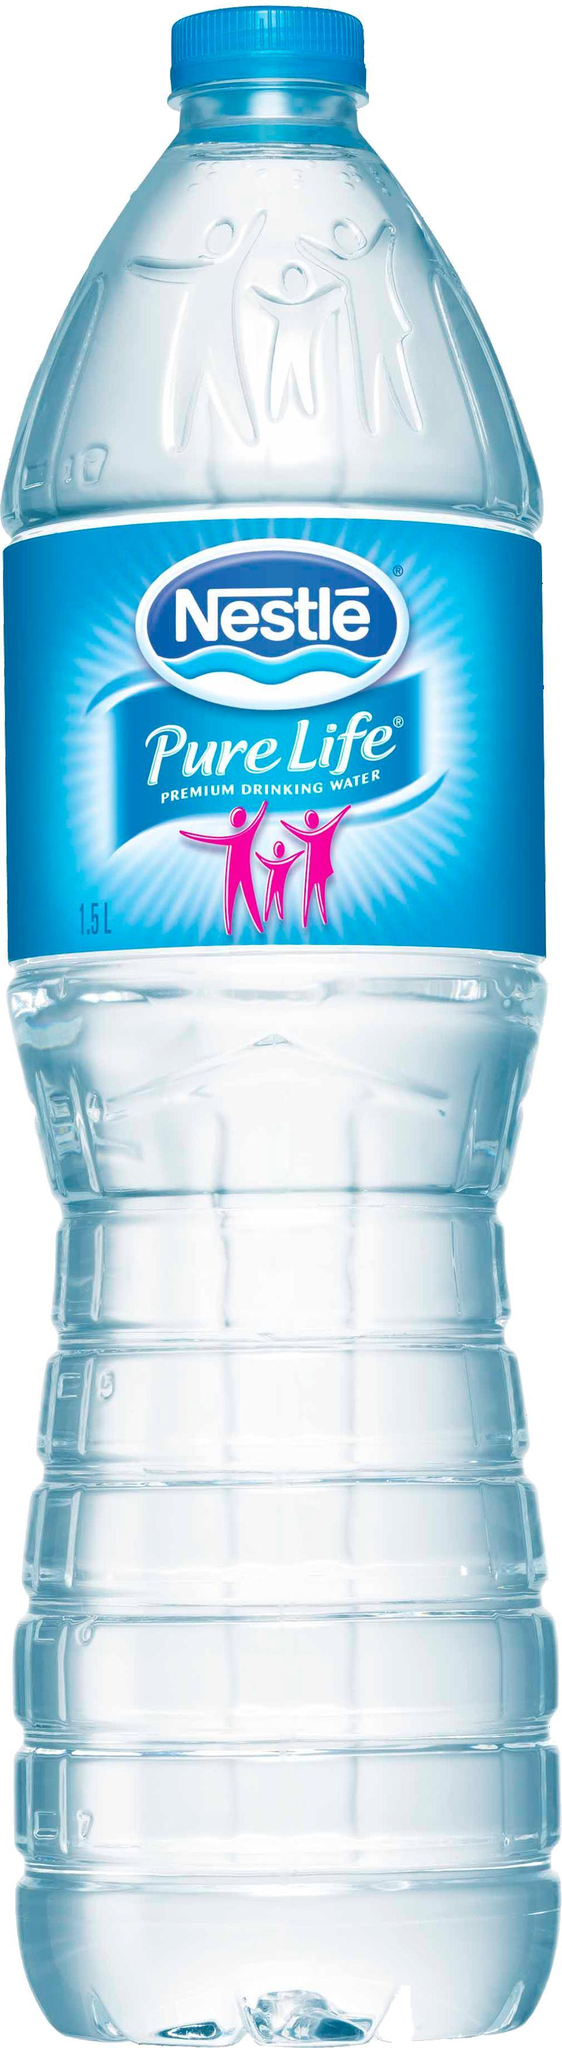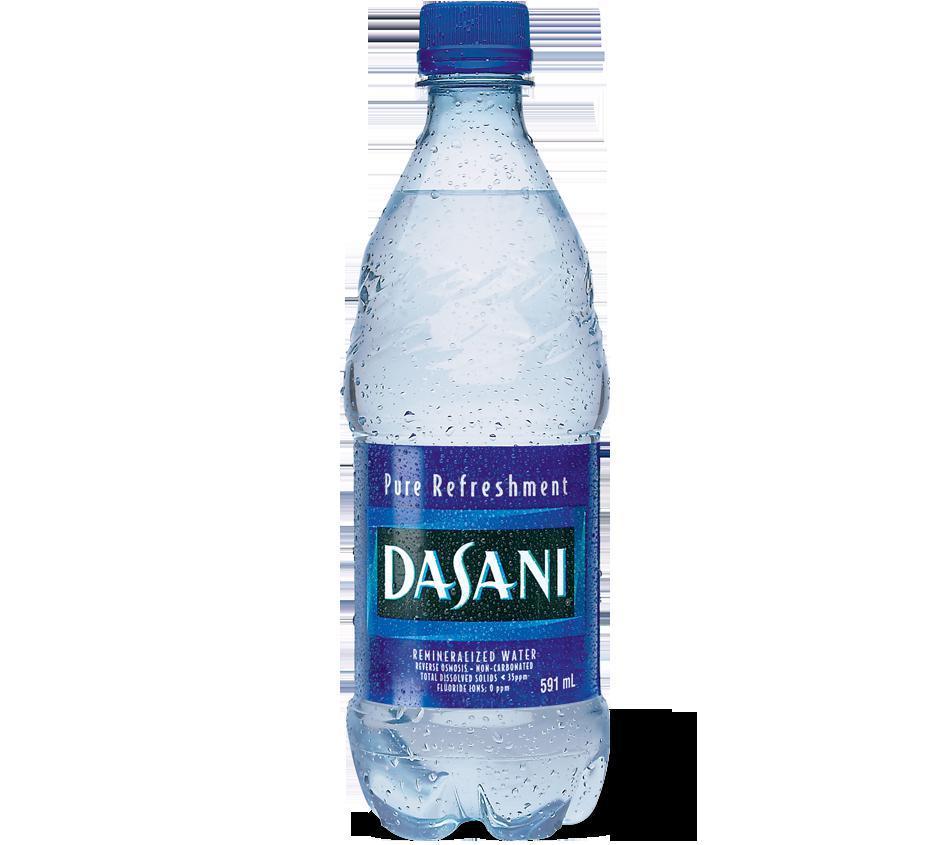The first image is the image on the left, the second image is the image on the right. Analyze the images presented: Is the assertion "An image shows at least one filled water bottle with a blue lid and no label." valid? Answer yes or no. No. The first image is the image on the left, the second image is the image on the right. Assess this claim about the two images: "None of the bottles have a label.". Correct or not? Answer yes or no. No. 